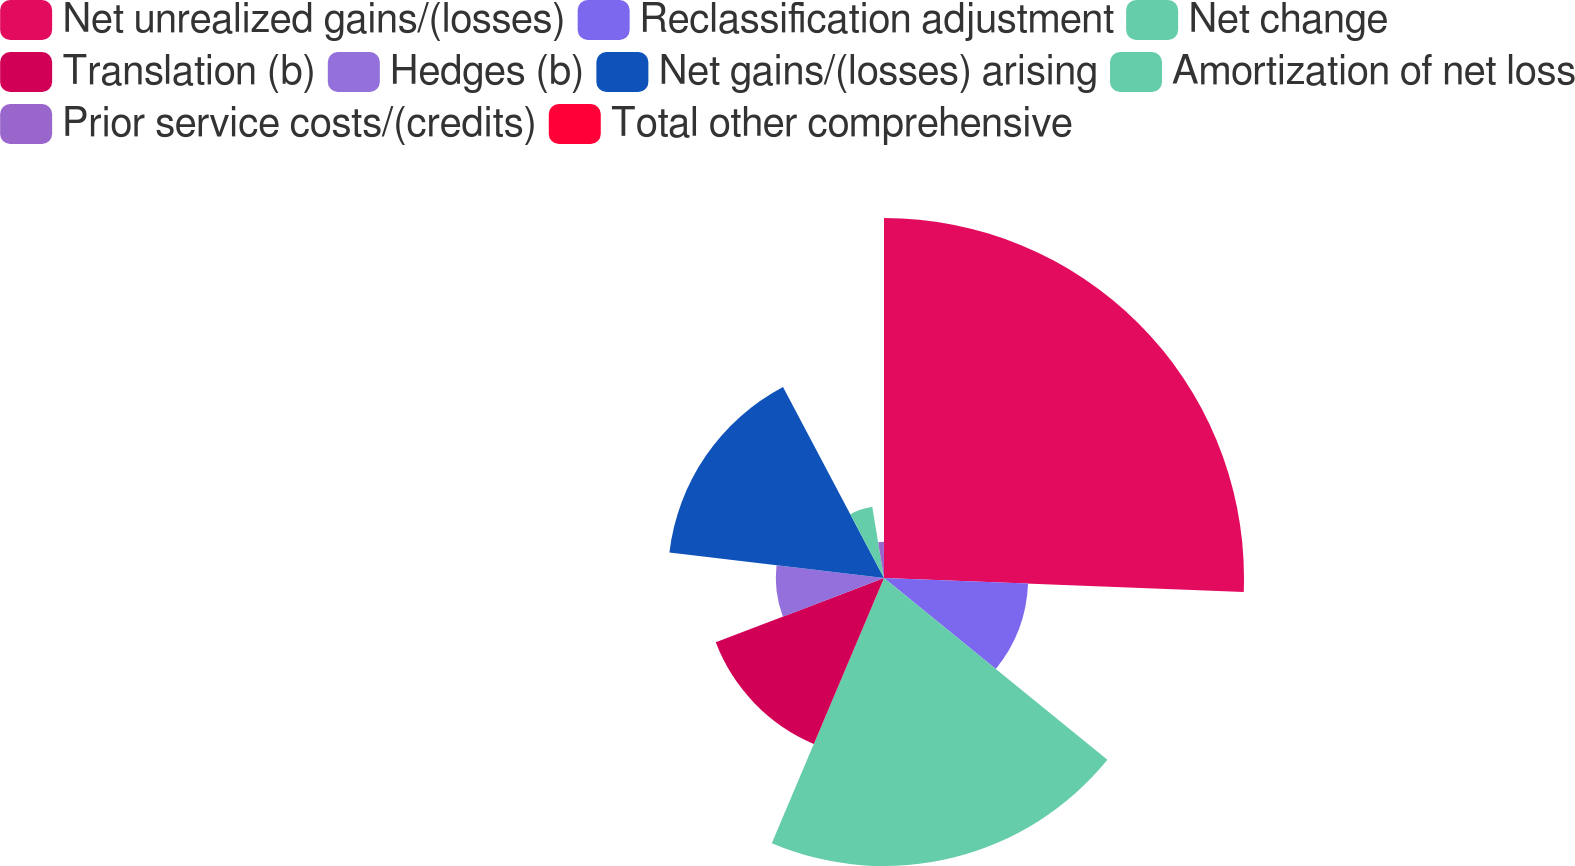Convert chart. <chart><loc_0><loc_0><loc_500><loc_500><pie_chart><fcel>Net unrealized gains/(losses)<fcel>Reclassification adjustment<fcel>Net change<fcel>Translation (b)<fcel>Hedges (b)<fcel>Net gains/(losses) arising<fcel>Amortization of net loss<fcel>Prior service costs/(credits)<fcel>Total other comprehensive<nl><fcel>25.62%<fcel>10.26%<fcel>20.5%<fcel>12.82%<fcel>7.7%<fcel>15.38%<fcel>5.14%<fcel>2.58%<fcel>0.02%<nl></chart> 